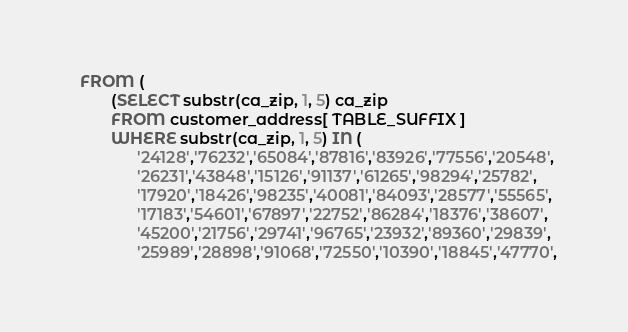Convert code to text. <code><loc_0><loc_0><loc_500><loc_500><_SQL_>  FROM (
         (SELECT substr(ca_zip, 1, 5) ca_zip
         FROM customer_address[ TABLE_SUFFIX ]
         WHERE substr(ca_zip, 1, 5) IN (
               '24128','76232','65084','87816','83926','77556','20548',
               '26231','43848','15126','91137','61265','98294','25782',
               '17920','18426','98235','40081','84093','28577','55565',
               '17183','54601','67897','22752','86284','18376','38607',
               '45200','21756','29741','96765','23932','89360','29839',
               '25989','28898','91068','72550','10390','18845','47770',</code> 